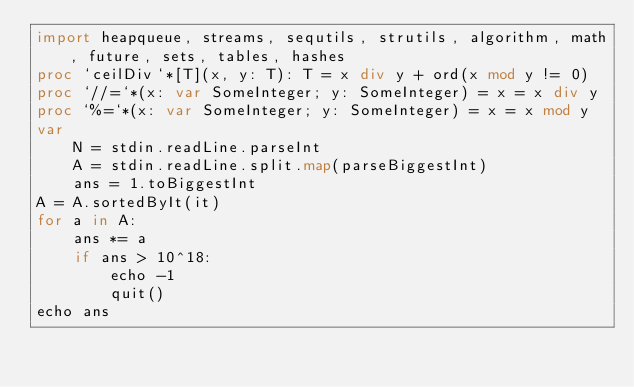Convert code to text. <code><loc_0><loc_0><loc_500><loc_500><_Nim_>import heapqueue, streams, sequtils, strutils, algorithm, math, future, sets, tables, hashes
proc `ceilDiv`*[T](x, y: T): T = x div y + ord(x mod y != 0)
proc `//=`*(x: var SomeInteger; y: SomeInteger) = x = x div y
proc `%=`*(x: var SomeInteger; y: SomeInteger) = x = x mod y
var
    N = stdin.readLine.parseInt
    A = stdin.readLine.split.map(parseBiggestInt)
    ans = 1.toBiggestInt
A = A.sortedByIt(it)
for a in A:
    ans *= a
    if ans > 10^18:
        echo -1
        quit()
echo ans</code> 